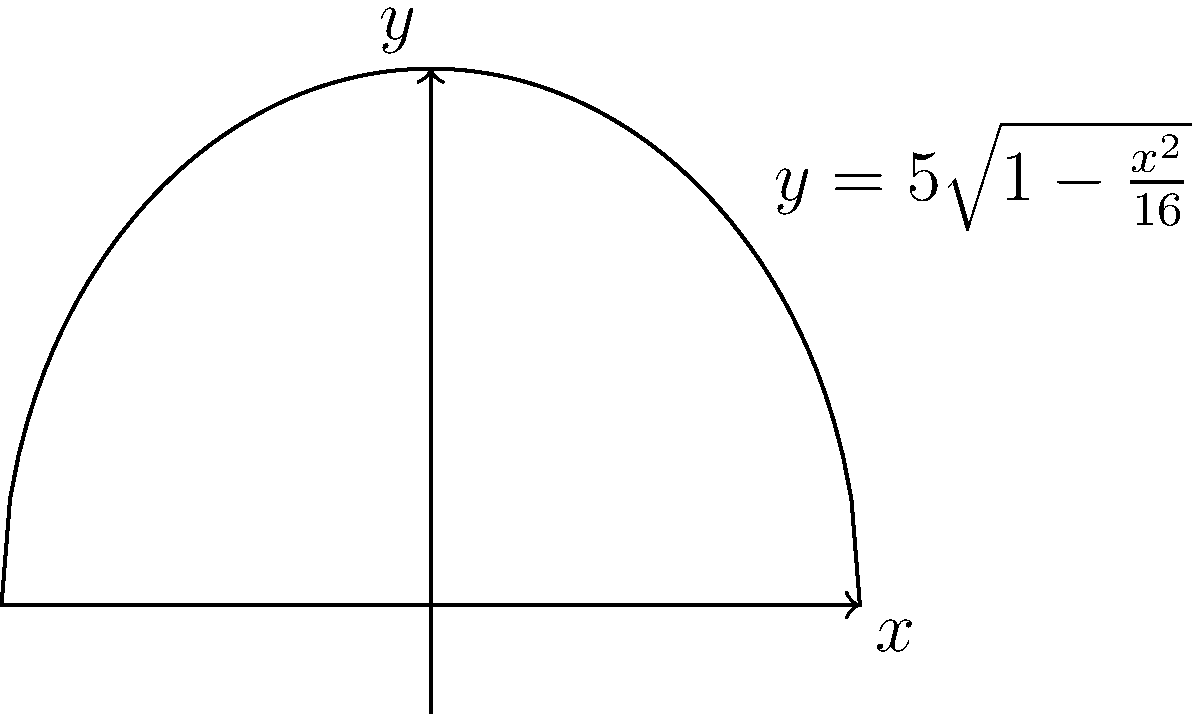As an art collector specializing in historical cathedral etchings, you've come across a unique dome design. The cross-section of the dome can be modeled by the equation $y=5\sqrt{1-\frac{x^2}{16}}$ for $-4 \leq x \leq 4$, where measurements are in meters. What is the volume of this dome when rotated around the y-axis? To find the volume of the dome, we need to use the method of rotating a curve around the y-axis. The steps are as follows:

1) The formula for the volume of a solid formed by rotating a curve $x=f(y)$ around the y-axis is:

   $$V = \pi \int_a^b [f(y)]^2 dy$$

2) We need to express x in terms of y. From the given equation:

   $$y=5\sqrt{1-\frac{x^2}{16}}$$

   $$\frac{y^2}{25} = 1-\frac{x^2}{16}$$

   $$\frac{x^2}{16} = 1-\frac{y^2}{25}$$

   $$x^2 = 16(1-\frac{y^2}{25}) = 16 - \frac{16y^2}{25}$$

   $$x = \sqrt{16 - \frac{16y^2}{25}}$$

3) The limits of integration are from y=0 to y=5 (the height of the dome).

4) Substituting into the volume formula:

   $$V = \pi \int_0^5 (16 - \frac{16y^2}{25}) dy$$

5) Simplifying:

   $$V = \pi \int_0^5 (16 - \frac{16y^2}{25}) dy = \pi [16y - \frac{16y^3}{75}]_0^5$$

6) Evaluating the integral:

   $$V = \pi [(16(5) - \frac{16(5^3)}{75}) - (16(0) - \frac{16(0^3)}{75})]$$

   $$V = \pi [80 - \frac{16(125)}{75}] = \pi [80 - \frac{2000}{75}] = \pi [\frac{6000-2000}{75}]$$

   $$V = \pi [\frac{4000}{75}] = \frac{4000\pi}{75} \approx 167.55 \text{ cubic meters}$$

Therefore, the volume of the dome is $\frac{4000\pi}{75}$ cubic meters.
Answer: $\frac{4000\pi}{75}$ cubic meters 